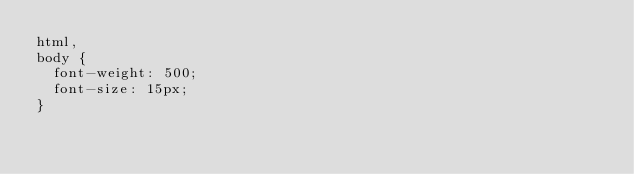<code> <loc_0><loc_0><loc_500><loc_500><_CSS_>html,
body {
  font-weight: 500;
  font-size: 15px;
}
</code> 